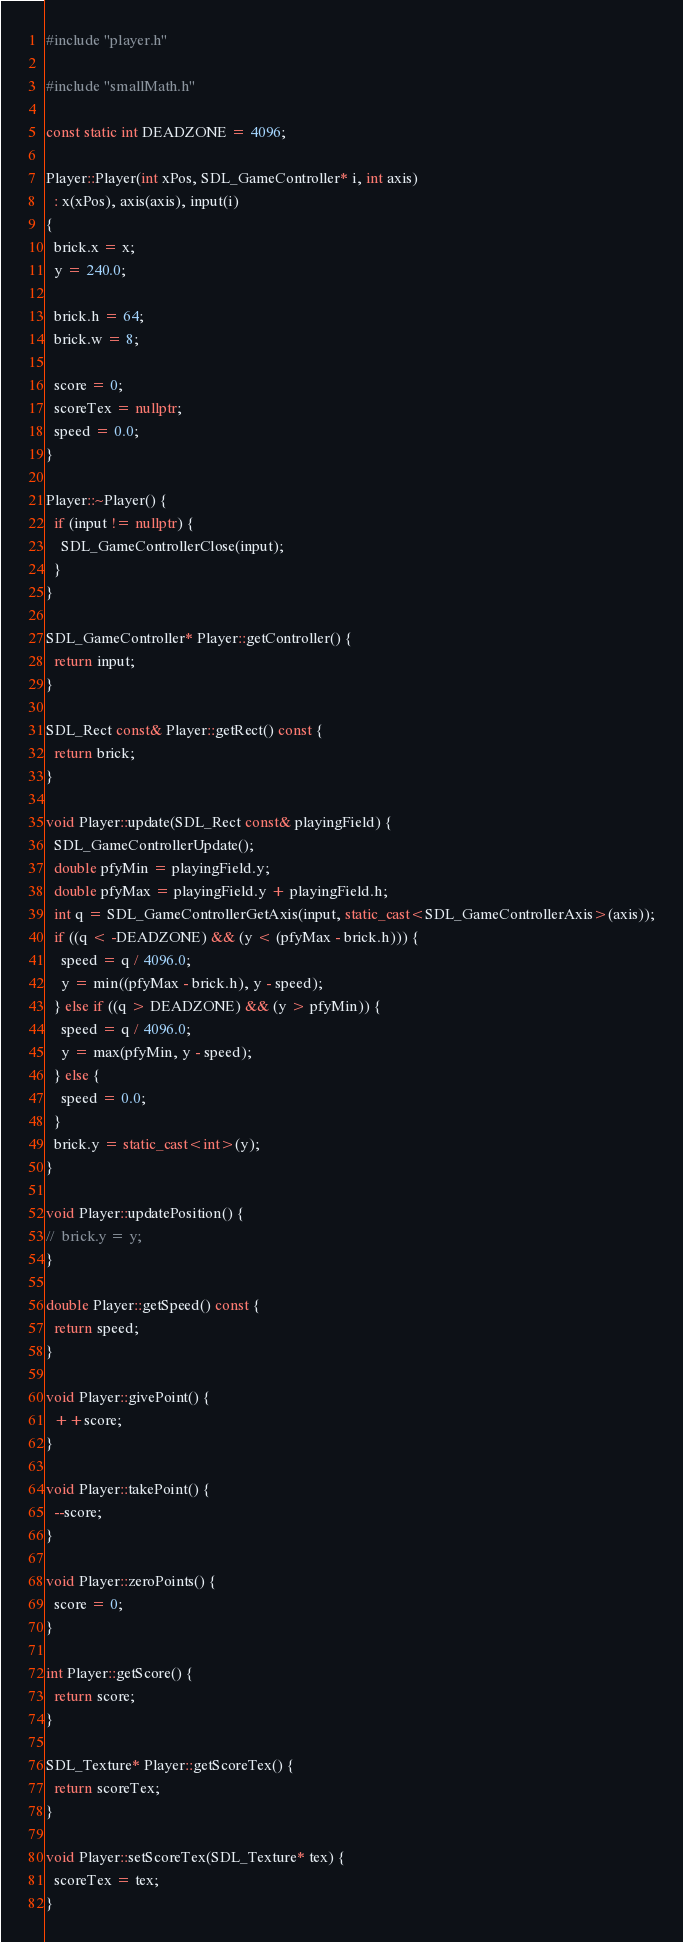Convert code to text. <code><loc_0><loc_0><loc_500><loc_500><_C++_>#include "player.h"

#include "smallMath.h"

const static int DEADZONE = 4096;

Player::Player(int xPos, SDL_GameController* i, int axis)
  : x(xPos), axis(axis), input(i)
{
  brick.x = x;
  y = 240.0;

  brick.h = 64;
  brick.w = 8;
  
  score = 0;
  scoreTex = nullptr;
  speed = 0.0;
}

Player::~Player() {
  if (input != nullptr) {
    SDL_GameControllerClose(input);
  }
}

SDL_GameController* Player::getController() {
  return input;
}

SDL_Rect const& Player::getRect() const {
  return brick;
}

void Player::update(SDL_Rect const& playingField) {
  SDL_GameControllerUpdate();
  double pfyMin = playingField.y;
  double pfyMax = playingField.y + playingField.h;
  int q = SDL_GameControllerGetAxis(input, static_cast<SDL_GameControllerAxis>(axis));
  if ((q < -DEADZONE) && (y < (pfyMax - brick.h))) {
    speed = q / 4096.0;
    y = min((pfyMax - brick.h), y - speed);
  } else if ((q > DEADZONE) && (y > pfyMin)) {
    speed = q / 4096.0;
    y = max(pfyMin, y - speed);
  } else {
    speed = 0.0;
  }
  brick.y = static_cast<int>(y);
}

void Player::updatePosition() {
//  brick.y = y;
}

double Player::getSpeed() const {
  return speed;
}

void Player::givePoint() {
  ++score;
}

void Player::takePoint() {
  --score;
}

void Player::zeroPoints() {
  score = 0;
}

int Player::getScore() {
  return score;
}

SDL_Texture* Player::getScoreTex() {
  return scoreTex;
}

void Player::setScoreTex(SDL_Texture* tex) {
  scoreTex = tex;
}
</code> 